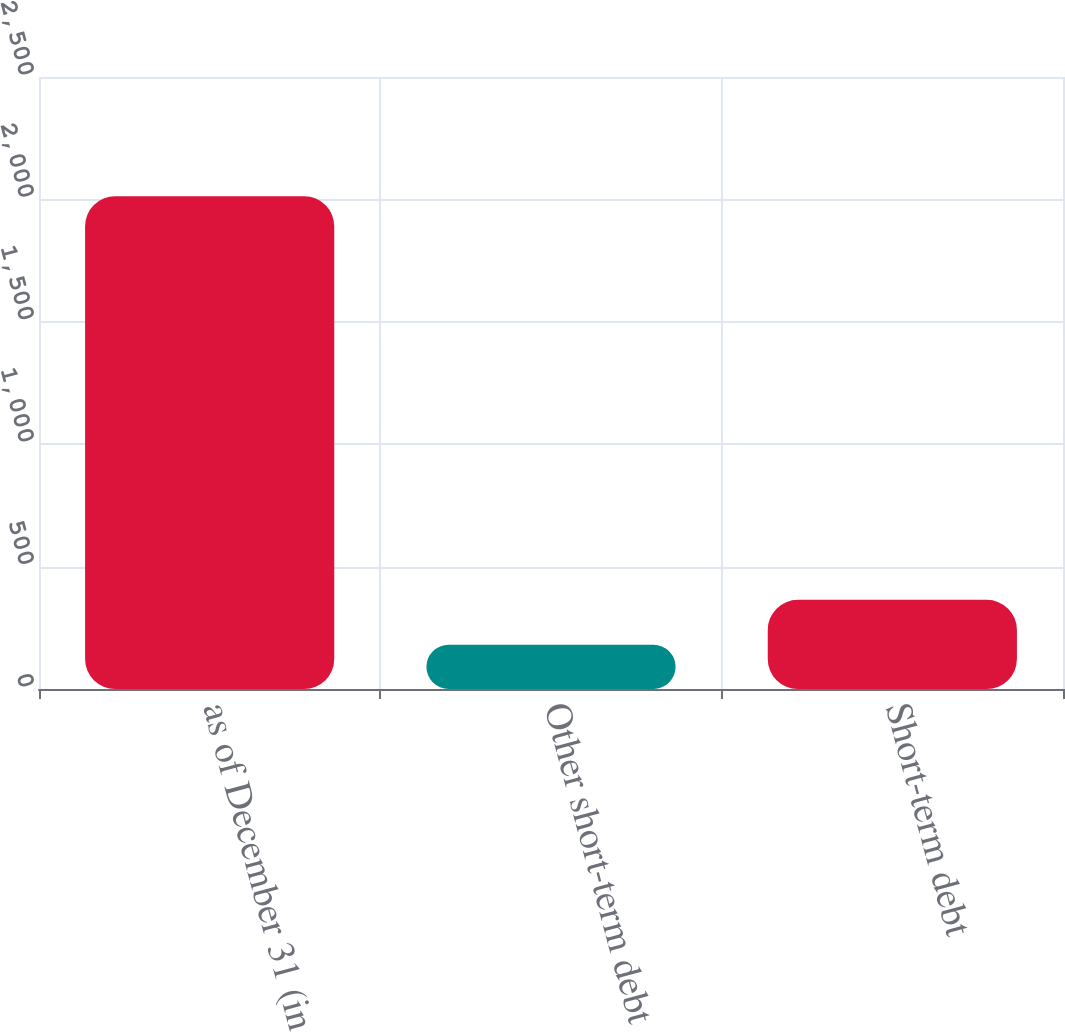<chart> <loc_0><loc_0><loc_500><loc_500><bar_chart><fcel>as of December 31 (in<fcel>Other short-term debt<fcel>Short-term debt<nl><fcel>2013<fcel>181<fcel>364.2<nl></chart> 